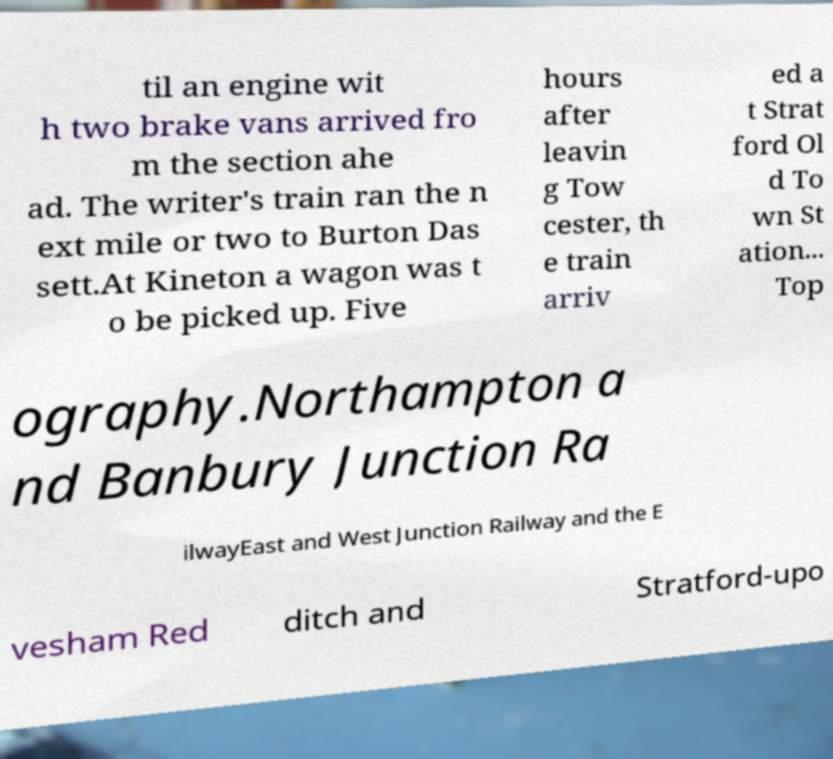Can you read and provide the text displayed in the image?This photo seems to have some interesting text. Can you extract and type it out for me? til an engine wit h two brake vans arrived fro m the section ahe ad. The writer's train ran the n ext mile or two to Burton Das sett.At Kineton a wagon was t o be picked up. Five hours after leavin g Tow cester, th e train arriv ed a t Strat ford Ol d To wn St ation... Top ography.Northampton a nd Banbury Junction Ra ilwayEast and West Junction Railway and the E vesham Red ditch and Stratford-upo 